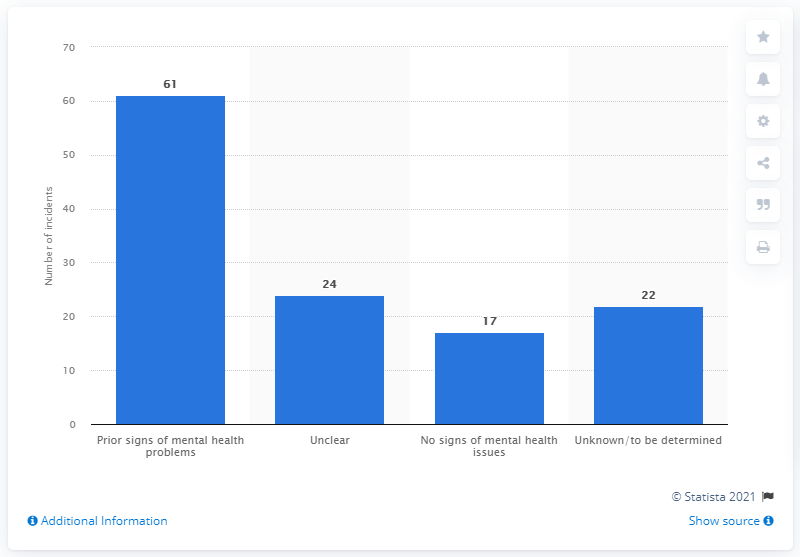Specify some key components in this picture. Sixty-one out of 124 reported mass shootings in the United States showed prior signs of mental health issues. Out of the 124 reported mass shootings, 17 cases showed no signs of mental health issues. 